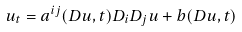Convert formula to latex. <formula><loc_0><loc_0><loc_500><loc_500>u _ { t } = a ^ { i j } ( D u , t ) D _ { i } D _ { j } u + b ( D u , t )</formula> 